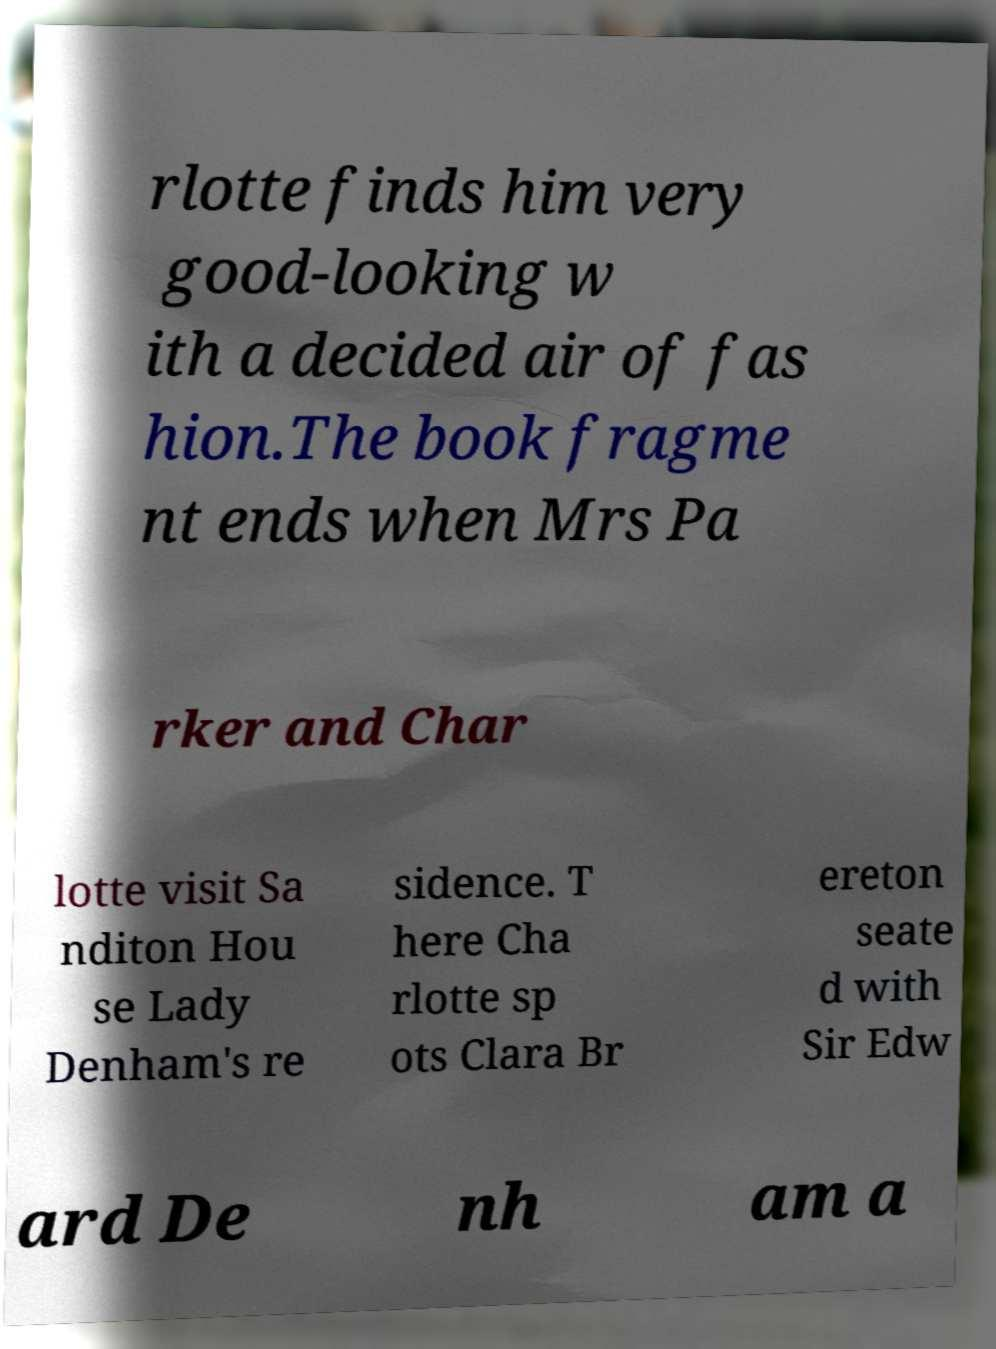Please read and relay the text visible in this image. What does it say? rlotte finds him very good-looking w ith a decided air of fas hion.The book fragme nt ends when Mrs Pa rker and Char lotte visit Sa nditon Hou se Lady Denham's re sidence. T here Cha rlotte sp ots Clara Br ereton seate d with Sir Edw ard De nh am a 